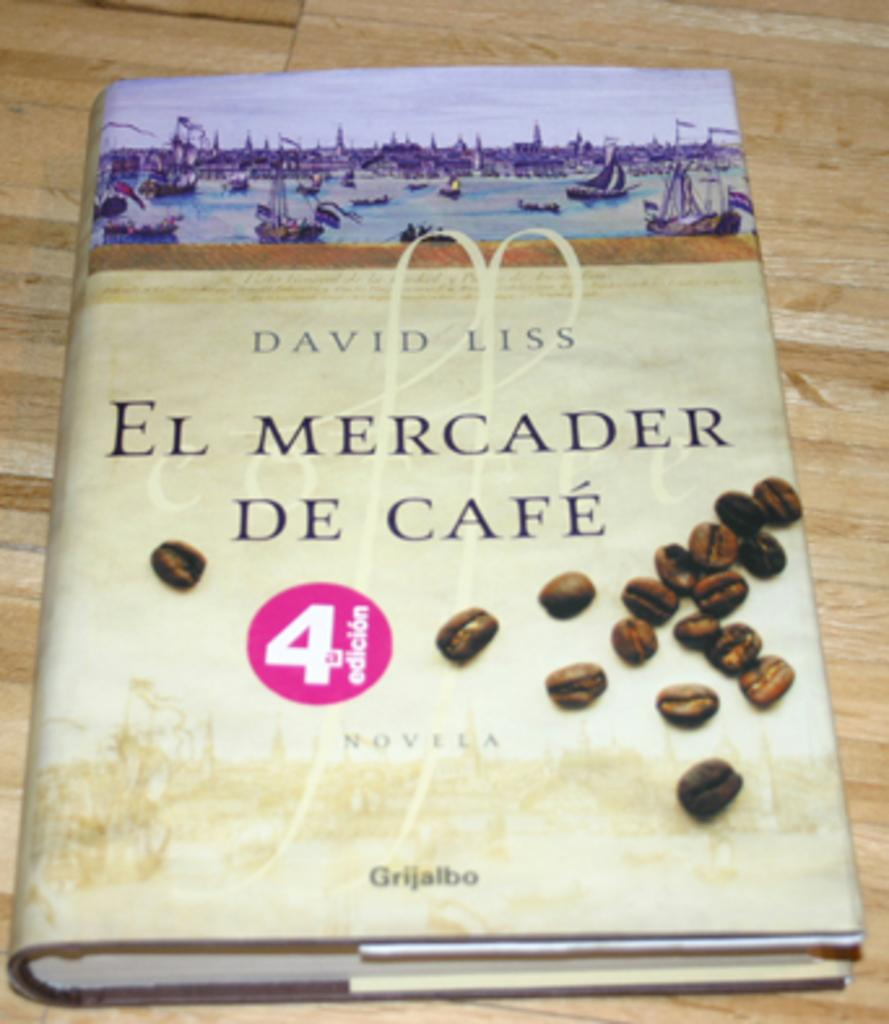Provide a one-sentence caption for the provided image. A Novela by David Liss called El Mercader De Cafe. 